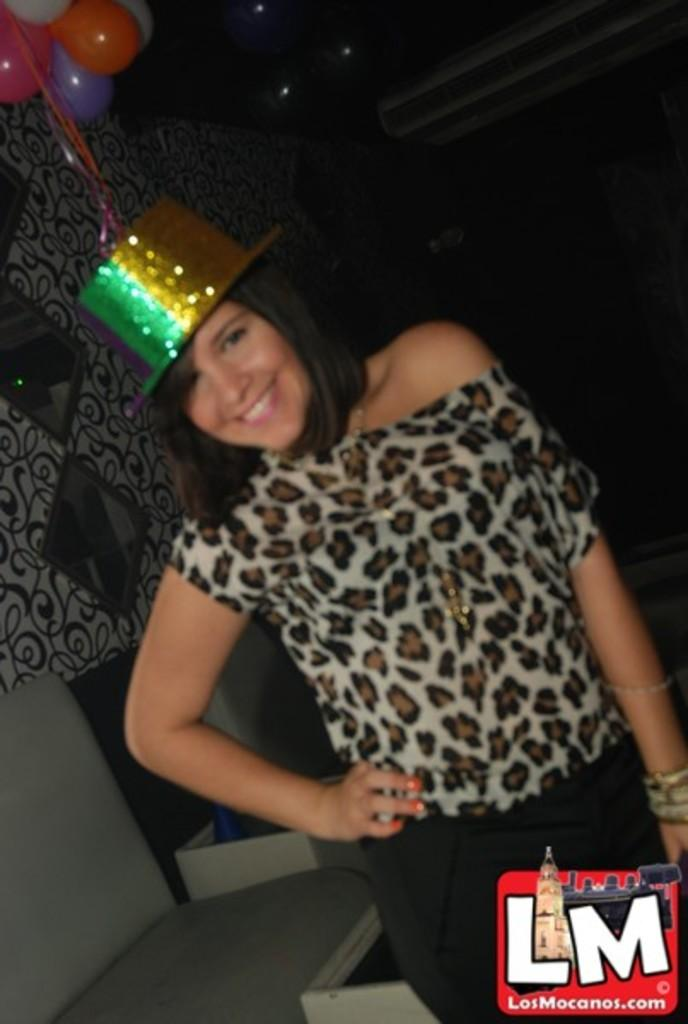Who is the main subject in the image? There is a woman standing in the center of the image. What is the woman standing on? The woman is standing on the ground. What can be seen in the background of the image? There are balloons, mirrors, and a wall in the background of the image. How many kisses can be seen in the image? There are no kisses present in the image. What type of adjustment is being made to the mirrors in the image? There is no indication in the image that any adjustments are being made to the mirrors. 